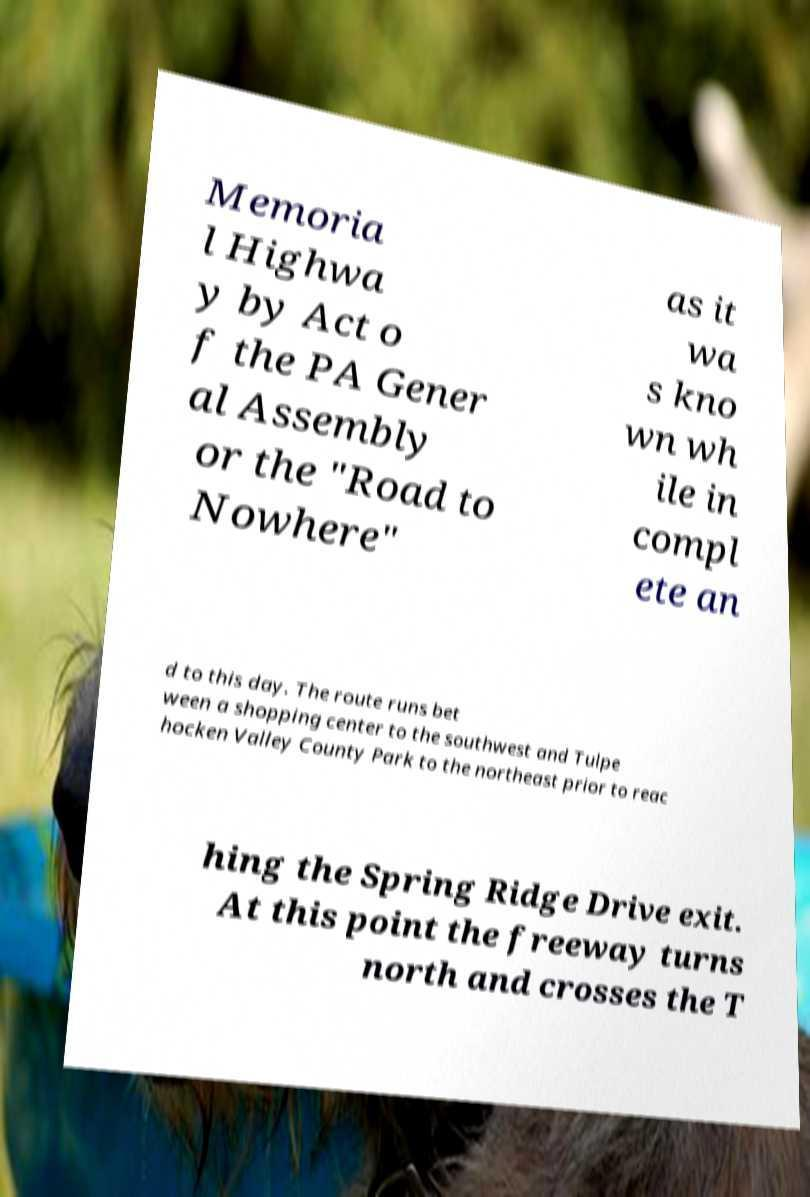Can you accurately transcribe the text from the provided image for me? Memoria l Highwa y by Act o f the PA Gener al Assembly or the "Road to Nowhere" as it wa s kno wn wh ile in compl ete an d to this day. The route runs bet ween a shopping center to the southwest and Tulpe hocken Valley County Park to the northeast prior to reac hing the Spring Ridge Drive exit. At this point the freeway turns north and crosses the T 